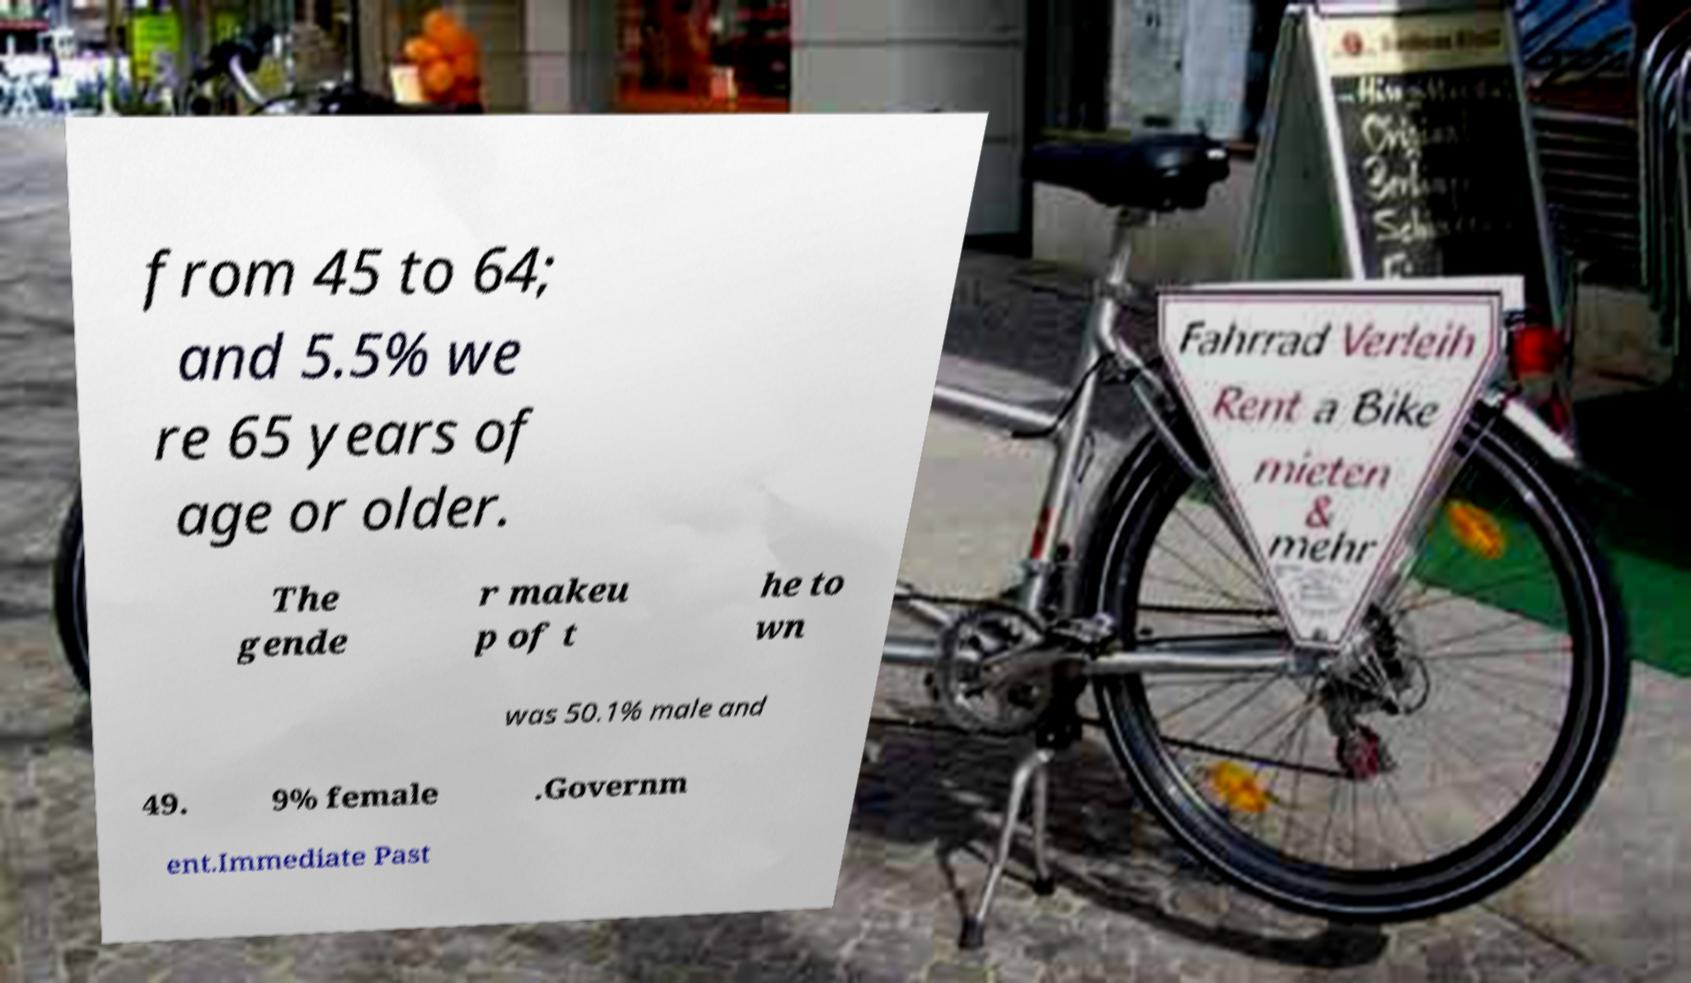Please read and relay the text visible in this image. What does it say? from 45 to 64; and 5.5% we re 65 years of age or older. The gende r makeu p of t he to wn was 50.1% male and 49. 9% female .Governm ent.Immediate Past 